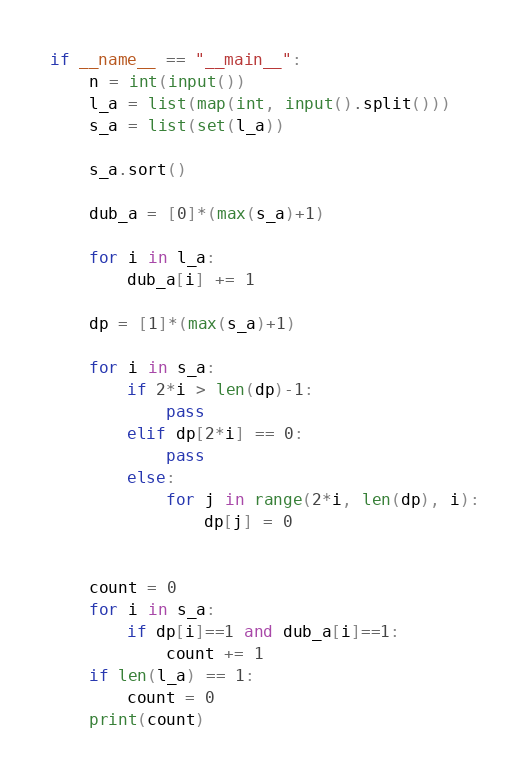<code> <loc_0><loc_0><loc_500><loc_500><_Python_>if __name__ == "__main__":
    n = int(input())
    l_a = list(map(int, input().split()))
    s_a = list(set(l_a))

    s_a.sort()

    dub_a = [0]*(max(s_a)+1)

    for i in l_a:
        dub_a[i] += 1

    dp = [1]*(max(s_a)+1)

    for i in s_a:
        if 2*i > len(dp)-1:
            pass
        elif dp[2*i] == 0:
            pass
        else:
            for j in range(2*i, len(dp), i):
                dp[j] = 0


    count = 0
    for i in s_a:
        if dp[i]==1 and dub_a[i]==1:
            count += 1
    if len(l_a) == 1:
        count = 0
    print(count)</code> 